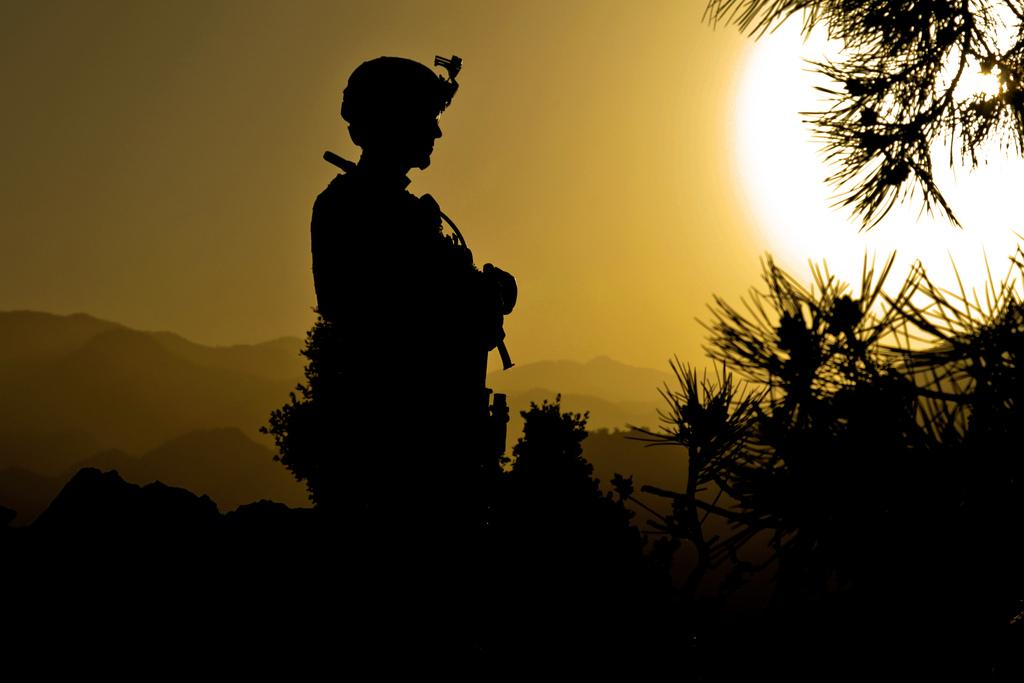When was the image taken? The image was taken during night. What type of natural elements can be seen in the image? There are trees and a hill visible in the image. Where is the light source located in the image? The light is visible on the right side of the image. Is there any indication of a sculpture in the image? There might be a person sculpture in the middle of the image. What is visible in the background of the image? The sky is visible in the image. Can you see any cherries growing on the trees in the image? There are no cherries visible in the image; only trees are present. Is there a town visible in the image? There is no town visible in the image; only trees, a hill, and a possible person sculpture are present. Is there a volcano visible in the image? There is no volcano visible in the image; only trees, a hill, and a possible person sculpture are present. 